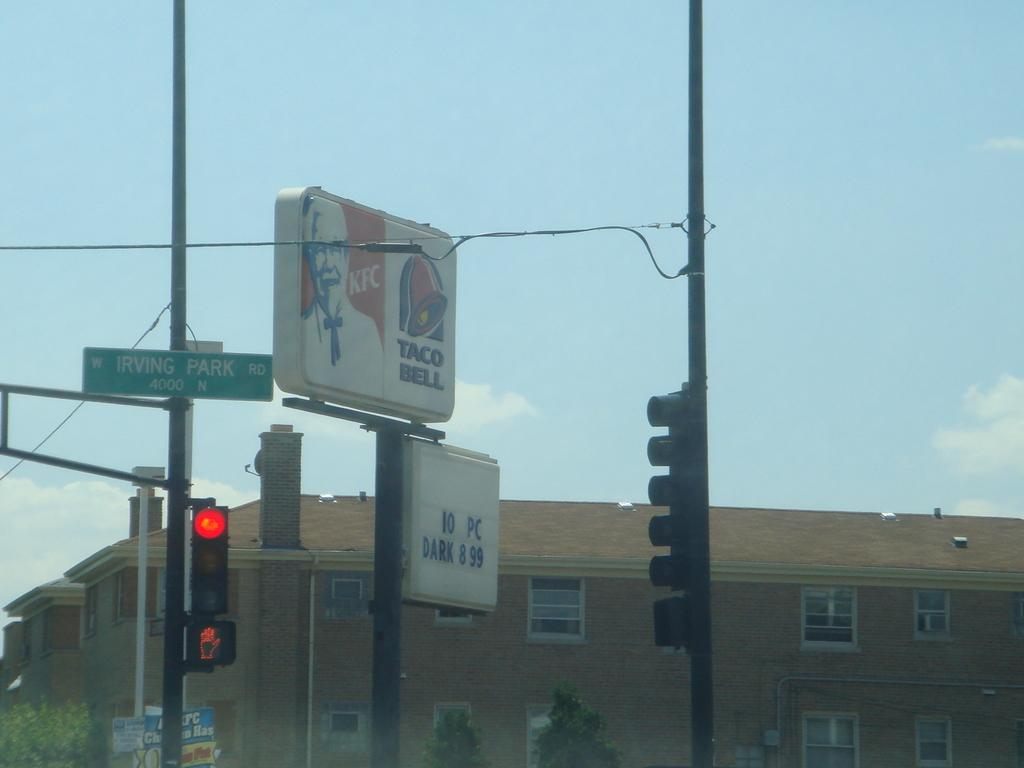Provide a one-sentence caption for the provided image. A splitsign that has Kentucky Friend Chicken and Taco Bell advertised. 